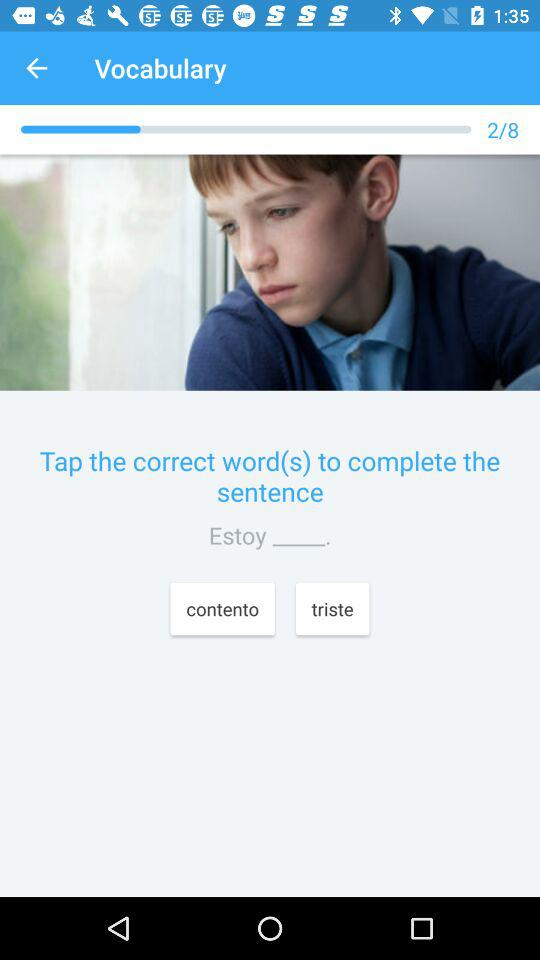What is the application name? The application name is "Vocabulary". 